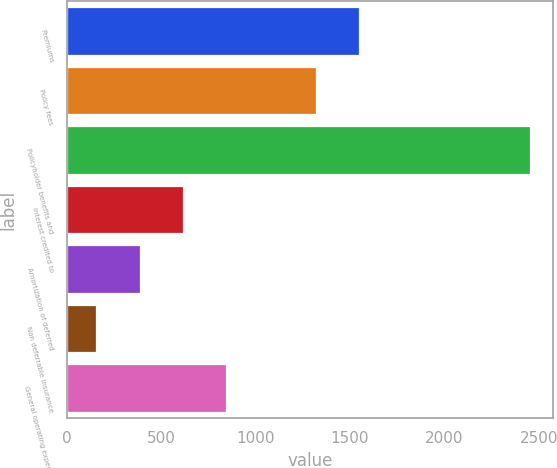<chart> <loc_0><loc_0><loc_500><loc_500><bar_chart><fcel>Premiums<fcel>Policy fees<fcel>Policyholder benefits and<fcel>Interest credited to<fcel>Amortization of deferred<fcel>Non deferrable insurance<fcel>General operating expenses<nl><fcel>1548.7<fcel>1319<fcel>2452<fcel>614.4<fcel>384.7<fcel>155<fcel>844.1<nl></chart> 